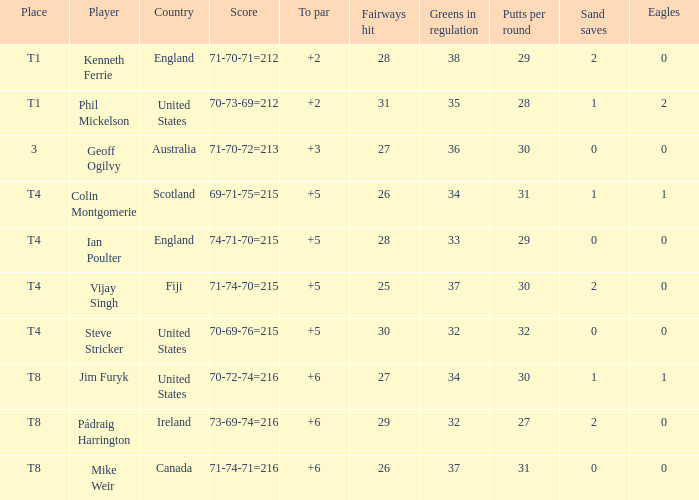What score to highest to par did Mike Weir achieve? 6.0. Could you parse the entire table? {'header': ['Place', 'Player', 'Country', 'Score', 'To par', 'Fairways hit', 'Greens in regulation', 'Putts per round', 'Sand saves', 'Eagles'], 'rows': [['T1', 'Kenneth Ferrie', 'England', '71-70-71=212', '+2', '28', '38', '29', '2', '0'], ['T1', 'Phil Mickelson', 'United States', '70-73-69=212', '+2', '31', '35', '28', '1', '2'], ['3', 'Geoff Ogilvy', 'Australia', '71-70-72=213', '+3', '27', '36', '30', '0', '0'], ['T4', 'Colin Montgomerie', 'Scotland', '69-71-75=215', '+5', '26', '34', '31', '1', '1'], ['T4', 'Ian Poulter', 'England', '74-71-70=215', '+5', '28', '33', '29', '0', '0'], ['T4', 'Vijay Singh', 'Fiji', '71-74-70=215', '+5', '25', '37', '30', '2', '0'], ['T4', 'Steve Stricker', 'United States', '70-69-76=215', '+5', '30', '32', '32', '0', '0'], ['T8', 'Jim Furyk', 'United States', '70-72-74=216', '+6', '27', '34', '30', '1', '1'], ['T8', 'Pádraig Harrington', 'Ireland', '73-69-74=216', '+6', '29', '32', '27', '2', '0'], ['T8', 'Mike Weir', 'Canada', '71-74-71=216', '+6', '26', '37', '31', '0', '0']]} 